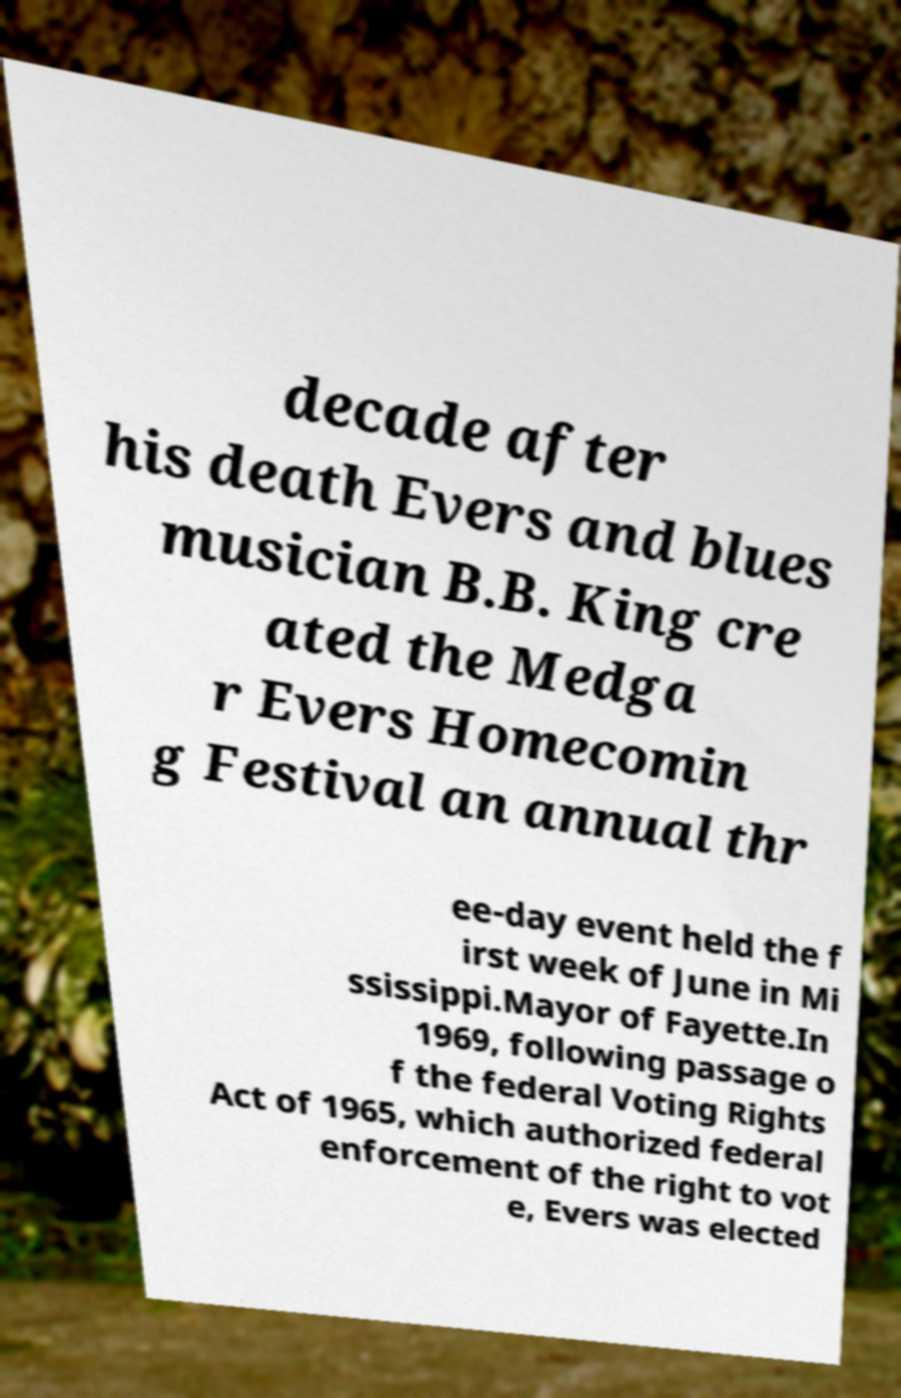Could you extract and type out the text from this image? decade after his death Evers and blues musician B.B. King cre ated the Medga r Evers Homecomin g Festival an annual thr ee-day event held the f irst week of June in Mi ssissippi.Mayor of Fayette.In 1969, following passage o f the federal Voting Rights Act of 1965, which authorized federal enforcement of the right to vot e, Evers was elected 